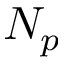Convert formula to latex. <formula><loc_0><loc_0><loc_500><loc_500>N _ { p }</formula> 